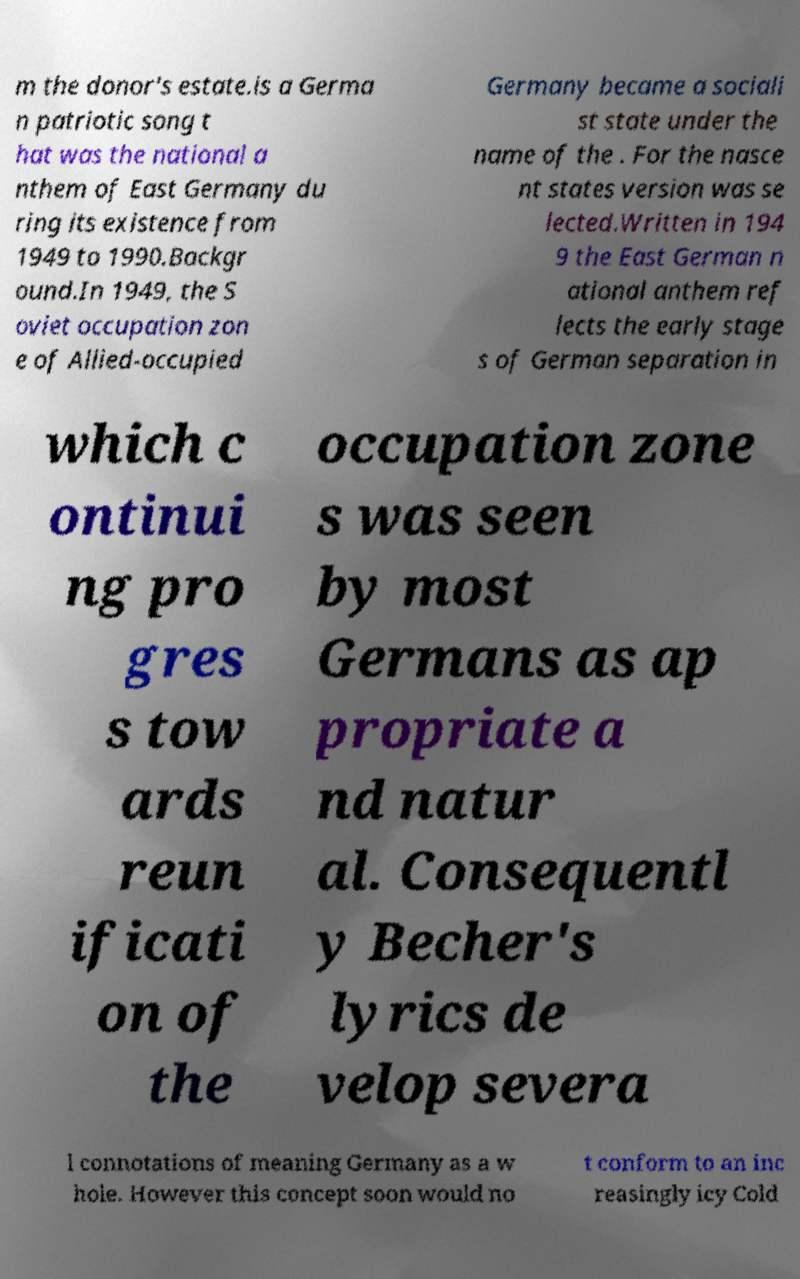Please identify and transcribe the text found in this image. m the donor's estate.is a Germa n patriotic song t hat was the national a nthem of East Germany du ring its existence from 1949 to 1990.Backgr ound.In 1949, the S oviet occupation zon e of Allied-occupied Germany became a sociali st state under the name of the . For the nasce nt states version was se lected.Written in 194 9 the East German n ational anthem ref lects the early stage s of German separation in which c ontinui ng pro gres s tow ards reun ificati on of the occupation zone s was seen by most Germans as ap propriate a nd natur al. Consequentl y Becher's lyrics de velop severa l connotations of meaning Germany as a w hole. However this concept soon would no t conform to an inc reasingly icy Cold 